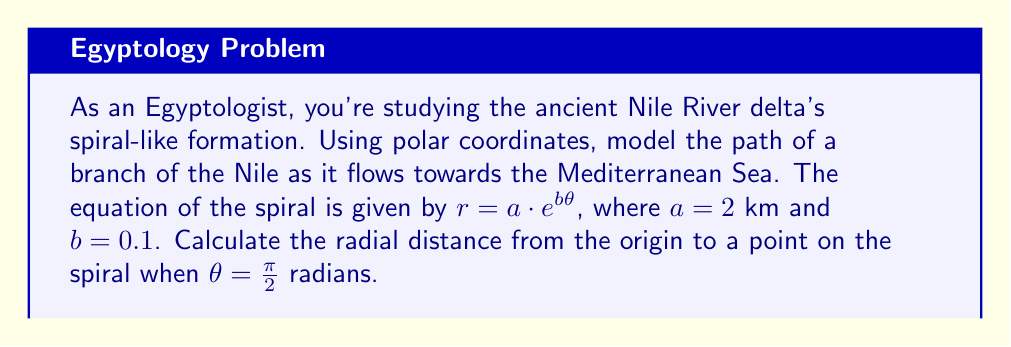Help me with this question. To solve this problem, we'll use the given polar equation and substitute the known values:

1) The general equation of the spiral is:
   $r = a \cdot e^{b\theta}$

2) We're given that:
   $a = 2$ km
   $b = 0.1$
   $\theta = \frac{\pi}{2}$ radians

3) Substituting these values into the equation:
   $r = 2 \cdot e^{0.1 \cdot \frac{\pi}{2}}$

4) Simplify the exponent:
   $r = 2 \cdot e^{0.1\pi/2}$

5) Calculate the value of $e^{0.1\pi/2}$:
   $e^{0.1\pi/2} \approx 1.1752$

6) Multiply by 2:
   $r = 2 \cdot 1.1752 \approx 2.3504$ km

Therefore, when $\theta = \frac{\pi}{2}$ radians, the radial distance from the origin to the point on the spiral is approximately 2.3504 km.

This model provides insight into how the Nile delta branch curves and expands as it approaches the Mediterranean, reflecting the importance of understanding local geographical features in archaeological studies beyond the typical European focus.
Answer: $r \approx 2.3504$ km 